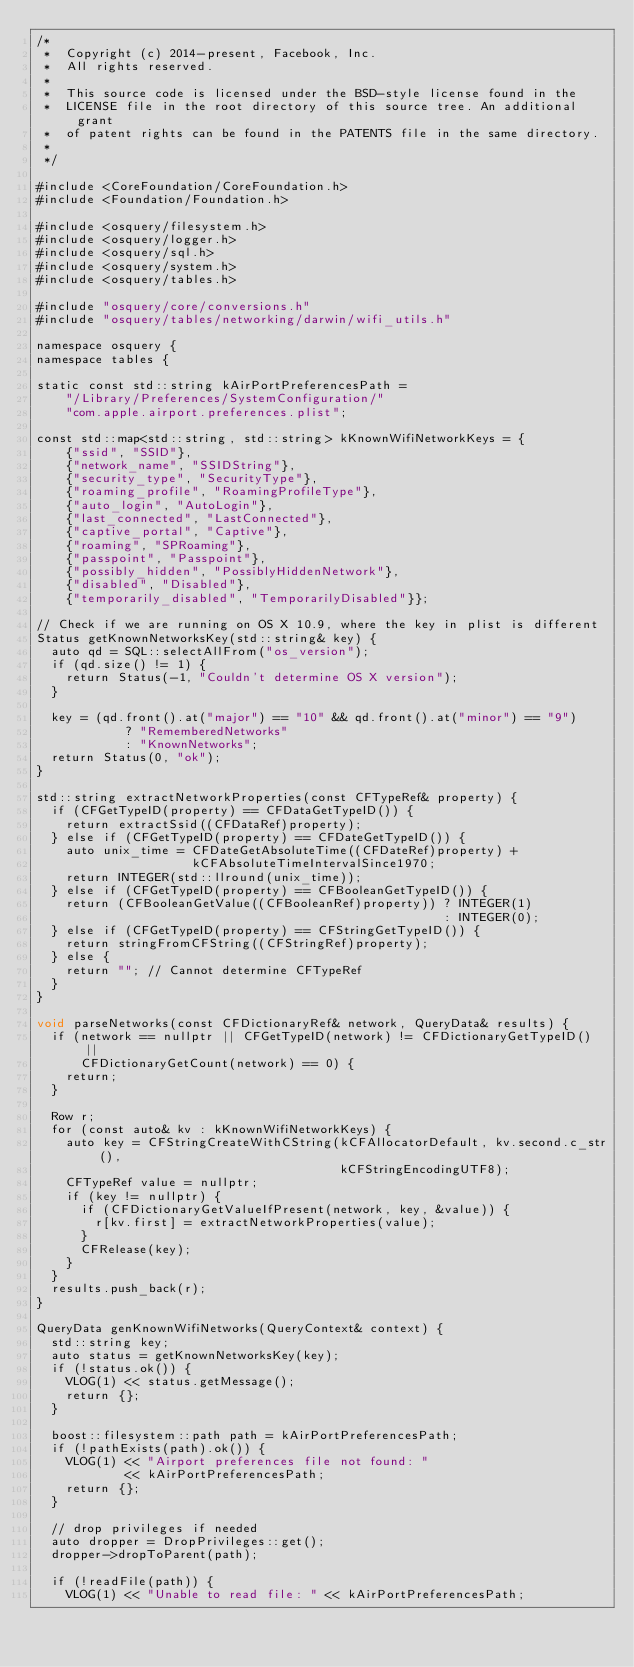<code> <loc_0><loc_0><loc_500><loc_500><_ObjectiveC_>/*
 *  Copyright (c) 2014-present, Facebook, Inc.
 *  All rights reserved.
 *
 *  This source code is licensed under the BSD-style license found in the
 *  LICENSE file in the root directory of this source tree. An additional grant
 *  of patent rights can be found in the PATENTS file in the same directory.
 *
 */

#include <CoreFoundation/CoreFoundation.h>
#include <Foundation/Foundation.h>

#include <osquery/filesystem.h>
#include <osquery/logger.h>
#include <osquery/sql.h>
#include <osquery/system.h>
#include <osquery/tables.h>

#include "osquery/core/conversions.h"
#include "osquery/tables/networking/darwin/wifi_utils.h"

namespace osquery {
namespace tables {

static const std::string kAirPortPreferencesPath =
    "/Library/Preferences/SystemConfiguration/"
    "com.apple.airport.preferences.plist";

const std::map<std::string, std::string> kKnownWifiNetworkKeys = {
    {"ssid", "SSID"},
    {"network_name", "SSIDString"},
    {"security_type", "SecurityType"},
    {"roaming_profile", "RoamingProfileType"},
    {"auto_login", "AutoLogin"},
    {"last_connected", "LastConnected"},
    {"captive_portal", "Captive"},
    {"roaming", "SPRoaming"},
    {"passpoint", "Passpoint"},
    {"possibly_hidden", "PossiblyHiddenNetwork"},
    {"disabled", "Disabled"},
    {"temporarily_disabled", "TemporarilyDisabled"}};

// Check if we are running on OS X 10.9, where the key in plist is different
Status getKnownNetworksKey(std::string& key) {
  auto qd = SQL::selectAllFrom("os_version");
  if (qd.size() != 1) {
    return Status(-1, "Couldn't determine OS X version");
  }

  key = (qd.front().at("major") == "10" && qd.front().at("minor") == "9")
            ? "RememberedNetworks"
            : "KnownNetworks";
  return Status(0, "ok");
}

std::string extractNetworkProperties(const CFTypeRef& property) {
  if (CFGetTypeID(property) == CFDataGetTypeID()) {
    return extractSsid((CFDataRef)property);
  } else if (CFGetTypeID(property) == CFDateGetTypeID()) {
    auto unix_time = CFDateGetAbsoluteTime((CFDateRef)property) +
                     kCFAbsoluteTimeIntervalSince1970;
    return INTEGER(std::llround(unix_time));
  } else if (CFGetTypeID(property) == CFBooleanGetTypeID()) {
    return (CFBooleanGetValue((CFBooleanRef)property)) ? INTEGER(1)
                                                       : INTEGER(0);
  } else if (CFGetTypeID(property) == CFStringGetTypeID()) {
    return stringFromCFString((CFStringRef)property);
  } else {
    return ""; // Cannot determine CFTypeRef
  }
}

void parseNetworks(const CFDictionaryRef& network, QueryData& results) {
  if (network == nullptr || CFGetTypeID(network) != CFDictionaryGetTypeID() ||
      CFDictionaryGetCount(network) == 0) {
    return;
  }

  Row r;
  for (const auto& kv : kKnownWifiNetworkKeys) {
    auto key = CFStringCreateWithCString(kCFAllocatorDefault, kv.second.c_str(),
                                         kCFStringEncodingUTF8);
    CFTypeRef value = nullptr;
    if (key != nullptr) {
      if (CFDictionaryGetValueIfPresent(network, key, &value)) {
        r[kv.first] = extractNetworkProperties(value);
      }
      CFRelease(key);
    }
  }
  results.push_back(r);
}

QueryData genKnownWifiNetworks(QueryContext& context) {
  std::string key;
  auto status = getKnownNetworksKey(key);
  if (!status.ok()) {
    VLOG(1) << status.getMessage();
    return {};
  }

  boost::filesystem::path path = kAirPortPreferencesPath;
  if (!pathExists(path).ok()) {
    VLOG(1) << "Airport preferences file not found: "
            << kAirPortPreferencesPath;
    return {};
  }

  // drop privileges if needed
  auto dropper = DropPrivileges::get();
  dropper->dropToParent(path);

  if (!readFile(path)) {
    VLOG(1) << "Unable to read file: " << kAirPortPreferencesPath;</code> 